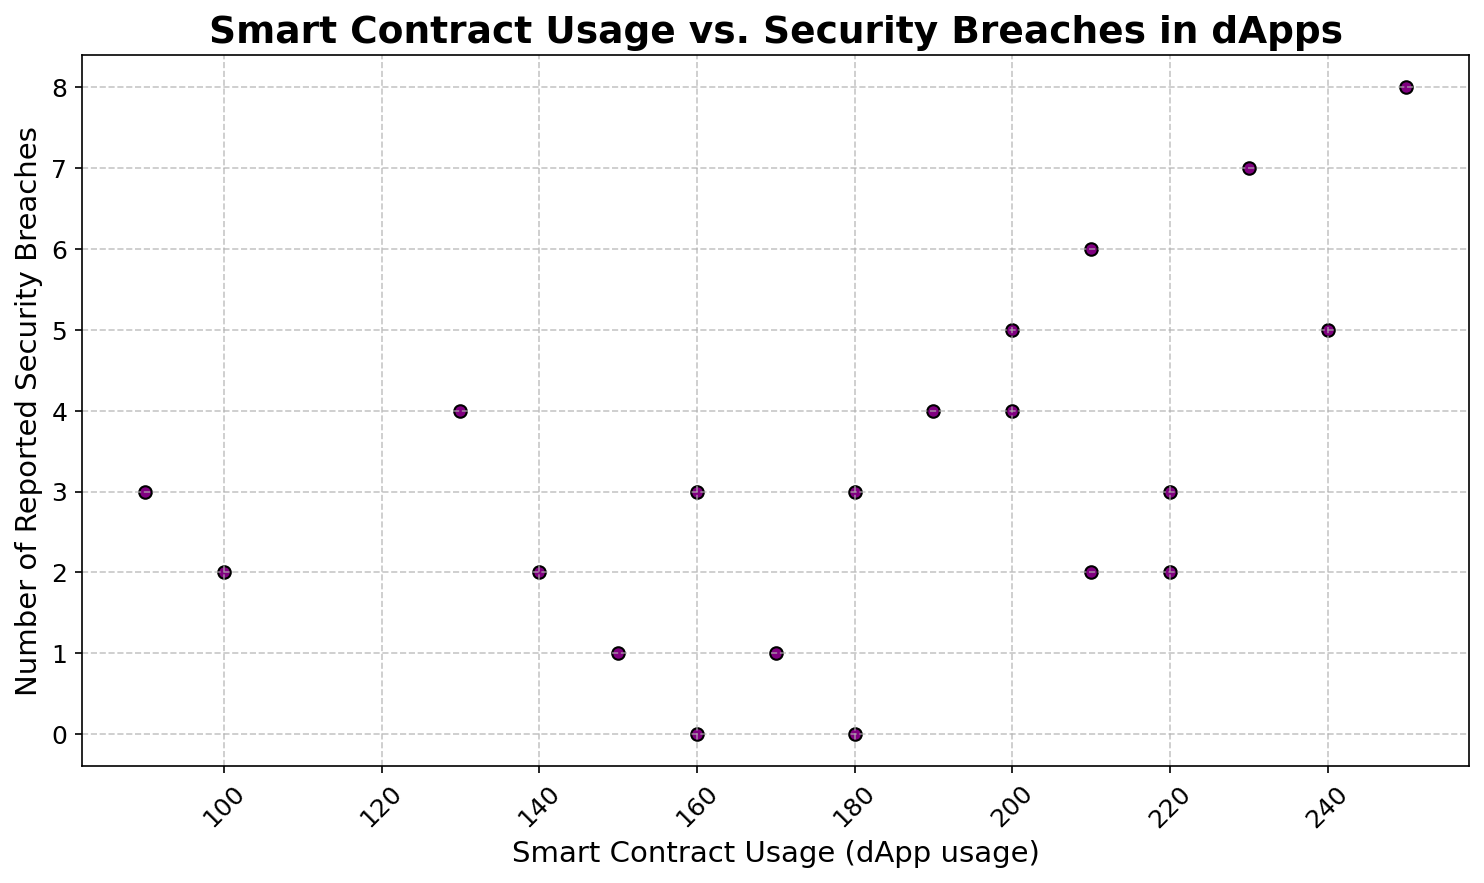What is the highest number of security breaches and what is the corresponding dApp usage value? The highest number of security breaches is found by looking at the y-axis for the maximum value. By inspecting the plot, this value is 8. The corresponding dApp usage is the x-axis value at this point, which is 250.
Answer: 8 breaches at 250 dApp usage Is there a clear relationship between the increase in dApp usage and the number of security breaches? To determine if there is a clear relationship, look for a pattern in how the points are distributed on the scatter plot. From the visual inspection, there is a noticeable trend where higher dApp usage seems to correlate with a higher number of security breaches, though it is not perfectly linear.
Answer: Positive correlation but not perfectly linear Which point on the scatter plot represents the lowest number of security breaches and what is the corresponding dApp usage? The lowest number of security breaches is 0. By finding the point(s) on the y-axis at 0, and checking the corresponding x-axis values, we see this occurs at dApp usage values of 160 and 180.
Answer: 0 breaches at 160 and 180 dApp usage How many instances have dApp usage above 200 and how many security breaches do they have on average? First identify all points with dApp usage above 200. They occur at 210, 220, 230, 240, and 250. The corresponding breaches are 6, 2, 7, 5, and 8 respectively. The average number of breaches is calculated by summing these (6 + 2 + 7 + 5 + 8 = 28) and dividing by the number of points (5), giving 28/5 = 5.6.
Answer: 5 instances, average 5.6 breaches What is the median number of security breaches for all recorded points? To find the median, first list all the breach values in ascending order: 0, 0, 1, 1, 2, 2, 2, 2, 3, 3, 3, 3, 4, 4, 4, 5, 5, 6, 7, 8. Since there are 20 values, the median is the average of the 10th and 11th values: (3+3)/2 = 3.
Answer: 3 Which timestamp has the highest dApp usage and how many security breaches occurred on that date? The highest dApp usage is 250. By finding the corresponding point, this occurs on 2023-01-16, with 8 security breaches.
Answer: 2023-01-16, 8 breaches Are there more instances of dApp usage below 150 or above 200? Count the instances. Below 150, dApp usage values are at 100, 90, 130, and 140 which makes 4 instances. Above 200, values are at 210, 220, 230, 240, and 250, making 5 instances. Therefore, there are more instances of dApp usage above 200.
Answer: Above 200 What proportion of points have exactly 3 security breaches? Identify the points with exactly 3 breaches. These occur at dApp usage values of 90, 180, 180, 220, for a total of 4 points. There are 20 points in total on the scatter plot. The proportion is 4/20, which simplifies to 0.2 or 20%.
Answer: 20% Which range of dApp usage has the densest cluster of points in terms of security breaches? Visually estimate the range where points are closely packed. The densest cluster appears to be within the range of dApp usage from 200 to 250, where many points are concentrated.
Answer: 200-250 On which date does the data point with the lowest dApp usage appear, and how many security breaches occurred on that date? The lowest dApp usage is 90. By identifying the corresponding date, this occurs on 2023-01-04, with 3 security breaches.
Answer: 2023-01-04, 3 breaches 